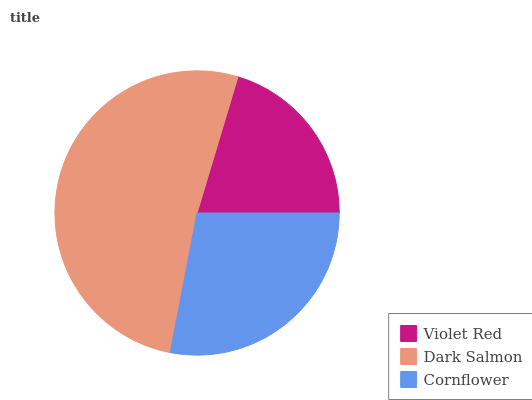Is Violet Red the minimum?
Answer yes or no. Yes. Is Dark Salmon the maximum?
Answer yes or no. Yes. Is Cornflower the minimum?
Answer yes or no. No. Is Cornflower the maximum?
Answer yes or no. No. Is Dark Salmon greater than Cornflower?
Answer yes or no. Yes. Is Cornflower less than Dark Salmon?
Answer yes or no. Yes. Is Cornflower greater than Dark Salmon?
Answer yes or no. No. Is Dark Salmon less than Cornflower?
Answer yes or no. No. Is Cornflower the high median?
Answer yes or no. Yes. Is Cornflower the low median?
Answer yes or no. Yes. Is Violet Red the high median?
Answer yes or no. No. Is Violet Red the low median?
Answer yes or no. No. 